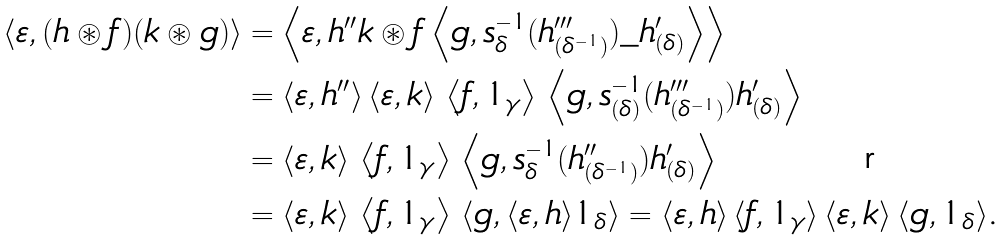Convert formula to latex. <formula><loc_0><loc_0><loc_500><loc_500>\left \langle \varepsilon , ( h \circledast f ) ( k \circledast g ) \right \rangle & = \left \langle \varepsilon , h ^ { \prime \prime } k \circledast f \left \langle g , s ^ { - 1 } _ { \delta } ( h ^ { \prime \prime \prime } _ { ( \delta ^ { - 1 } ) } ) \_ h ^ { \prime } _ { ( \delta ) } \right \rangle \right \rangle \\ & = \langle \varepsilon , h ^ { \prime \prime } \rangle \, \langle \varepsilon , k \rangle \, \left \langle f , 1 _ { \gamma } \right \rangle \, \left \langle g , s ^ { - 1 } _ { ( \delta ) } ( h ^ { \prime \prime \prime } _ { ( \delta ^ { - 1 } ) } ) h ^ { \prime } _ { ( \delta ) } \right \rangle \\ & = \langle \varepsilon , k \rangle \, \left \langle f , 1 _ { \gamma } \right \rangle \, \left \langle g , s ^ { - 1 } _ { \delta } ( h ^ { \prime \prime } _ { ( \delta ^ { - 1 } ) } ) h ^ { \prime } _ { ( \delta ) } \right \rangle \\ & = \langle \varepsilon , k \rangle \, \left \langle f , 1 _ { \gamma } \right \rangle \, \left \langle g , \langle \varepsilon , h \rangle 1 _ { \delta } \right \rangle = \langle \varepsilon , h \rangle \, \langle f , 1 _ { \gamma } \rangle \, \langle \varepsilon , k \rangle \, \langle g , 1 _ { \delta } \rangle \text {.}</formula> 